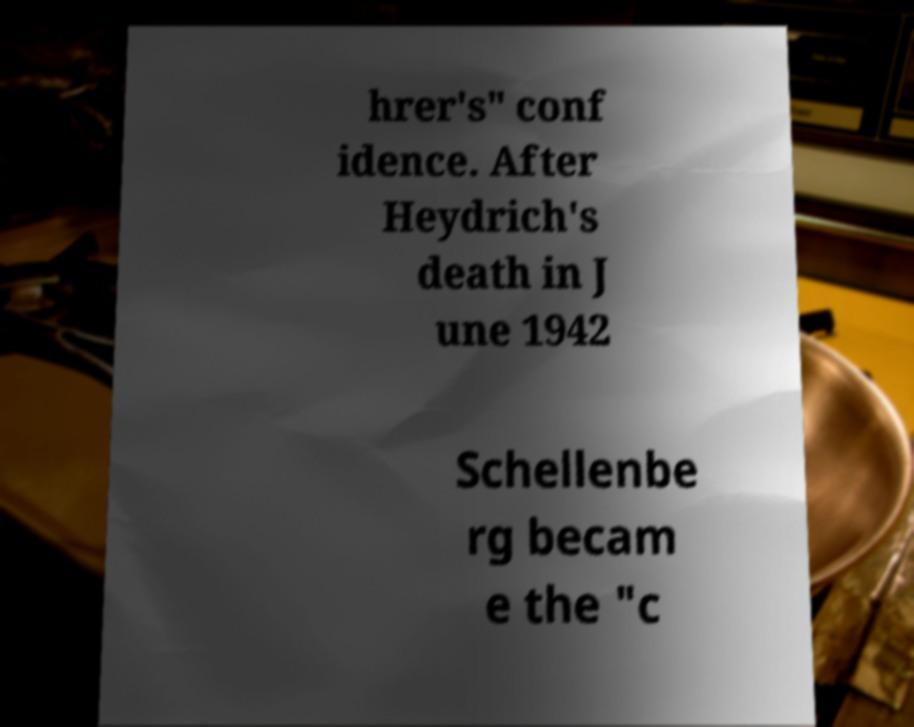Can you accurately transcribe the text from the provided image for me? hrer's" conf idence. After Heydrich's death in J une 1942 Schellenbe rg becam e the "c 